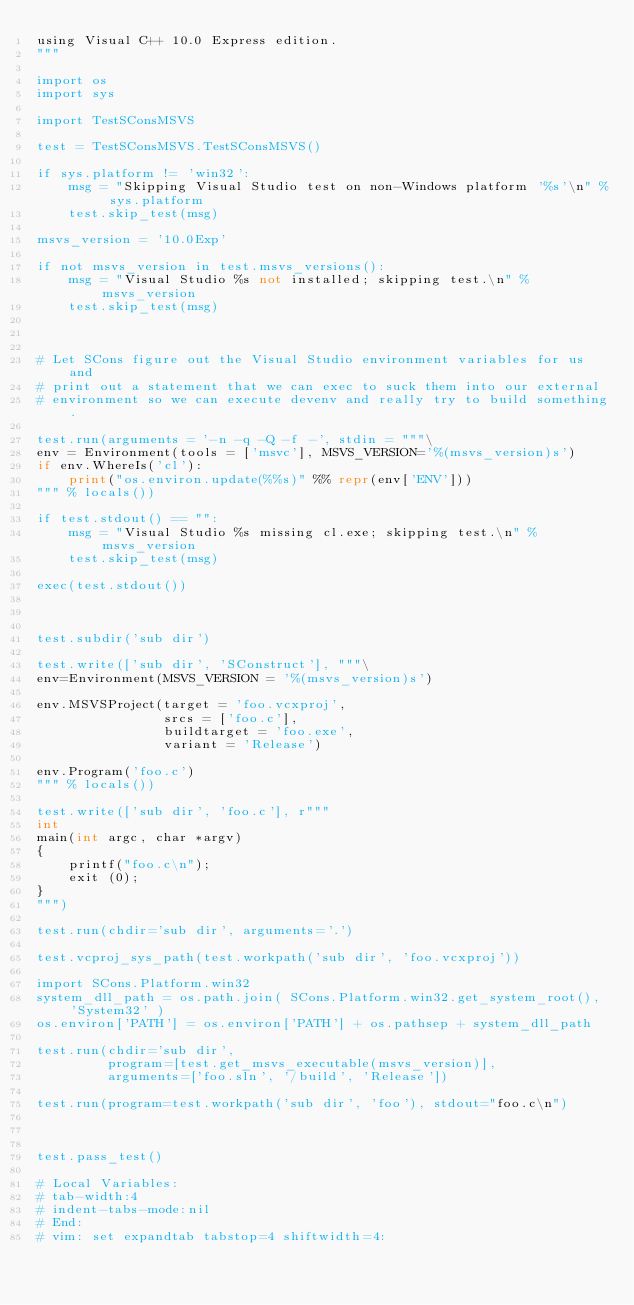<code> <loc_0><loc_0><loc_500><loc_500><_Python_>using Visual C++ 10.0 Express edition.
"""

import os
import sys

import TestSConsMSVS

test = TestSConsMSVS.TestSConsMSVS()

if sys.platform != 'win32':
    msg = "Skipping Visual Studio test on non-Windows platform '%s'\n" % sys.platform
    test.skip_test(msg)

msvs_version = '10.0Exp'

if not msvs_version in test.msvs_versions():
    msg = "Visual Studio %s not installed; skipping test.\n" % msvs_version
    test.skip_test(msg)



# Let SCons figure out the Visual Studio environment variables for us and
# print out a statement that we can exec to suck them into our external
# environment so we can execute devenv and really try to build something.

test.run(arguments = '-n -q -Q -f -', stdin = """\
env = Environment(tools = ['msvc'], MSVS_VERSION='%(msvs_version)s')
if env.WhereIs('cl'):
    print("os.environ.update(%%s)" %% repr(env['ENV']))
""" % locals())

if test.stdout() == "":
    msg = "Visual Studio %s missing cl.exe; skipping test.\n" % msvs_version
    test.skip_test(msg)

exec(test.stdout())



test.subdir('sub dir')

test.write(['sub dir', 'SConstruct'], """\
env=Environment(MSVS_VERSION = '%(msvs_version)s')

env.MSVSProject(target = 'foo.vcxproj',
                srcs = ['foo.c'],
                buildtarget = 'foo.exe',
                variant = 'Release')

env.Program('foo.c')
""" % locals())

test.write(['sub dir', 'foo.c'], r"""
int
main(int argc, char *argv)
{
    printf("foo.c\n");
    exit (0);
}
""")

test.run(chdir='sub dir', arguments='.')

test.vcproj_sys_path(test.workpath('sub dir', 'foo.vcxproj'))

import SCons.Platform.win32
system_dll_path = os.path.join( SCons.Platform.win32.get_system_root(), 'System32' )
os.environ['PATH'] = os.environ['PATH'] + os.pathsep + system_dll_path

test.run(chdir='sub dir',
         program=[test.get_msvs_executable(msvs_version)],
         arguments=['foo.sln', '/build', 'Release'])

test.run(program=test.workpath('sub dir', 'foo'), stdout="foo.c\n")



test.pass_test()

# Local Variables:
# tab-width:4
# indent-tabs-mode:nil
# End:
# vim: set expandtab tabstop=4 shiftwidth=4:
</code> 